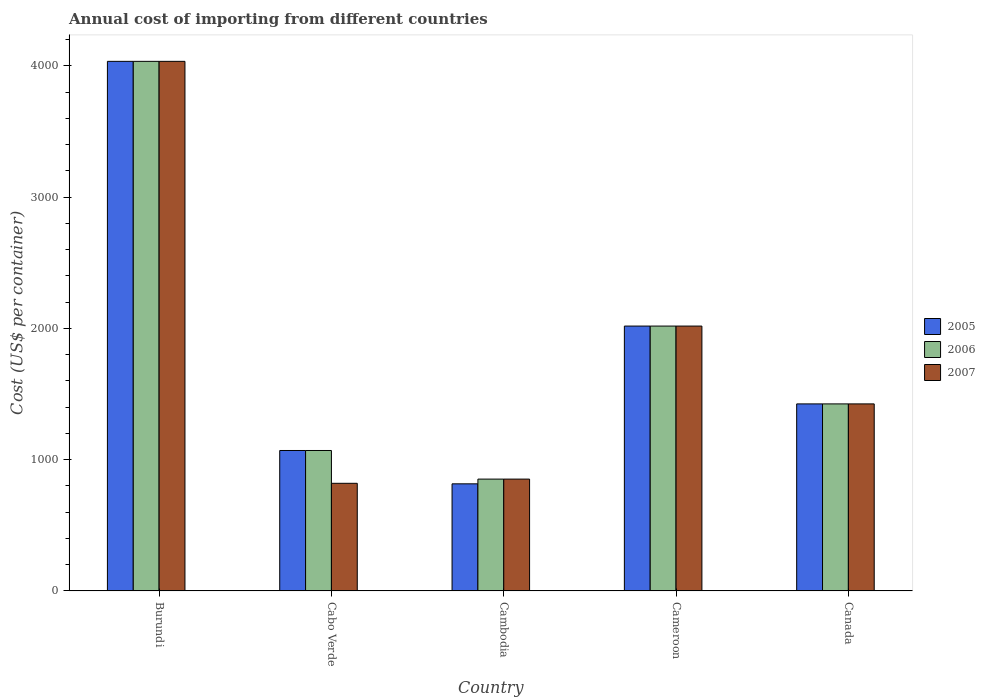How many bars are there on the 3rd tick from the right?
Your answer should be compact. 3. What is the label of the 3rd group of bars from the left?
Offer a very short reply. Cambodia. In how many cases, is the number of bars for a given country not equal to the number of legend labels?
Provide a succinct answer. 0. What is the total annual cost of importing in 2006 in Cameroon?
Keep it short and to the point. 2018. Across all countries, what is the maximum total annual cost of importing in 2007?
Provide a short and direct response. 4035. Across all countries, what is the minimum total annual cost of importing in 2007?
Offer a very short reply. 820. In which country was the total annual cost of importing in 2007 maximum?
Give a very brief answer. Burundi. In which country was the total annual cost of importing in 2006 minimum?
Ensure brevity in your answer.  Cambodia. What is the total total annual cost of importing in 2005 in the graph?
Ensure brevity in your answer.  9364. What is the difference between the total annual cost of importing in 2007 in Cabo Verde and that in Cameroon?
Provide a succinct answer. -1198. What is the difference between the total annual cost of importing in 2007 in Cameroon and the total annual cost of importing in 2005 in Cabo Verde?
Offer a very short reply. 948. What is the average total annual cost of importing in 2007 per country?
Make the answer very short. 1830. What is the difference between the total annual cost of importing of/in 2007 and total annual cost of importing of/in 2006 in Cambodia?
Provide a succinct answer. 0. In how many countries, is the total annual cost of importing in 2006 greater than 200 US$?
Offer a terse response. 5. What is the ratio of the total annual cost of importing in 2005 in Cabo Verde to that in Cambodia?
Ensure brevity in your answer.  1.31. Is the total annual cost of importing in 2005 in Cambodia less than that in Canada?
Ensure brevity in your answer.  Yes. What is the difference between the highest and the second highest total annual cost of importing in 2005?
Ensure brevity in your answer.  -593. What is the difference between the highest and the lowest total annual cost of importing in 2006?
Make the answer very short. 3183. In how many countries, is the total annual cost of importing in 2007 greater than the average total annual cost of importing in 2007 taken over all countries?
Your response must be concise. 2. What does the 3rd bar from the left in Cambodia represents?
Your answer should be very brief. 2007. What does the 1st bar from the right in Cambodia represents?
Offer a very short reply. 2007. Is it the case that in every country, the sum of the total annual cost of importing in 2007 and total annual cost of importing in 2005 is greater than the total annual cost of importing in 2006?
Your answer should be compact. Yes. Are all the bars in the graph horizontal?
Offer a terse response. No. How many countries are there in the graph?
Provide a succinct answer. 5. Does the graph contain grids?
Give a very brief answer. No. Where does the legend appear in the graph?
Make the answer very short. Center right. What is the title of the graph?
Offer a terse response. Annual cost of importing from different countries. What is the label or title of the X-axis?
Make the answer very short. Country. What is the label or title of the Y-axis?
Your answer should be very brief. Cost (US$ per container). What is the Cost (US$ per container) of 2005 in Burundi?
Your answer should be very brief. 4035. What is the Cost (US$ per container) of 2006 in Burundi?
Offer a terse response. 4035. What is the Cost (US$ per container) in 2007 in Burundi?
Make the answer very short. 4035. What is the Cost (US$ per container) in 2005 in Cabo Verde?
Your answer should be very brief. 1070. What is the Cost (US$ per container) in 2006 in Cabo Verde?
Offer a very short reply. 1070. What is the Cost (US$ per container) in 2007 in Cabo Verde?
Keep it short and to the point. 820. What is the Cost (US$ per container) in 2005 in Cambodia?
Your answer should be very brief. 816. What is the Cost (US$ per container) of 2006 in Cambodia?
Provide a succinct answer. 852. What is the Cost (US$ per container) in 2007 in Cambodia?
Offer a terse response. 852. What is the Cost (US$ per container) of 2005 in Cameroon?
Ensure brevity in your answer.  2018. What is the Cost (US$ per container) in 2006 in Cameroon?
Your response must be concise. 2018. What is the Cost (US$ per container) in 2007 in Cameroon?
Keep it short and to the point. 2018. What is the Cost (US$ per container) in 2005 in Canada?
Ensure brevity in your answer.  1425. What is the Cost (US$ per container) in 2006 in Canada?
Your response must be concise. 1425. What is the Cost (US$ per container) in 2007 in Canada?
Keep it short and to the point. 1425. Across all countries, what is the maximum Cost (US$ per container) in 2005?
Make the answer very short. 4035. Across all countries, what is the maximum Cost (US$ per container) of 2006?
Give a very brief answer. 4035. Across all countries, what is the maximum Cost (US$ per container) of 2007?
Provide a succinct answer. 4035. Across all countries, what is the minimum Cost (US$ per container) in 2005?
Keep it short and to the point. 816. Across all countries, what is the minimum Cost (US$ per container) of 2006?
Your answer should be compact. 852. Across all countries, what is the minimum Cost (US$ per container) in 2007?
Keep it short and to the point. 820. What is the total Cost (US$ per container) of 2005 in the graph?
Give a very brief answer. 9364. What is the total Cost (US$ per container) of 2006 in the graph?
Provide a short and direct response. 9400. What is the total Cost (US$ per container) in 2007 in the graph?
Keep it short and to the point. 9150. What is the difference between the Cost (US$ per container) of 2005 in Burundi and that in Cabo Verde?
Make the answer very short. 2965. What is the difference between the Cost (US$ per container) of 2006 in Burundi and that in Cabo Verde?
Provide a succinct answer. 2965. What is the difference between the Cost (US$ per container) in 2007 in Burundi and that in Cabo Verde?
Provide a succinct answer. 3215. What is the difference between the Cost (US$ per container) in 2005 in Burundi and that in Cambodia?
Offer a terse response. 3219. What is the difference between the Cost (US$ per container) in 2006 in Burundi and that in Cambodia?
Ensure brevity in your answer.  3183. What is the difference between the Cost (US$ per container) of 2007 in Burundi and that in Cambodia?
Your answer should be very brief. 3183. What is the difference between the Cost (US$ per container) of 2005 in Burundi and that in Cameroon?
Your answer should be compact. 2017. What is the difference between the Cost (US$ per container) of 2006 in Burundi and that in Cameroon?
Your response must be concise. 2017. What is the difference between the Cost (US$ per container) in 2007 in Burundi and that in Cameroon?
Your response must be concise. 2017. What is the difference between the Cost (US$ per container) of 2005 in Burundi and that in Canada?
Make the answer very short. 2610. What is the difference between the Cost (US$ per container) in 2006 in Burundi and that in Canada?
Make the answer very short. 2610. What is the difference between the Cost (US$ per container) in 2007 in Burundi and that in Canada?
Provide a succinct answer. 2610. What is the difference between the Cost (US$ per container) of 2005 in Cabo Verde and that in Cambodia?
Keep it short and to the point. 254. What is the difference between the Cost (US$ per container) of 2006 in Cabo Verde and that in Cambodia?
Provide a succinct answer. 218. What is the difference between the Cost (US$ per container) of 2007 in Cabo Verde and that in Cambodia?
Provide a short and direct response. -32. What is the difference between the Cost (US$ per container) in 2005 in Cabo Verde and that in Cameroon?
Your answer should be very brief. -948. What is the difference between the Cost (US$ per container) in 2006 in Cabo Verde and that in Cameroon?
Your answer should be very brief. -948. What is the difference between the Cost (US$ per container) in 2007 in Cabo Verde and that in Cameroon?
Keep it short and to the point. -1198. What is the difference between the Cost (US$ per container) in 2005 in Cabo Verde and that in Canada?
Your response must be concise. -355. What is the difference between the Cost (US$ per container) of 2006 in Cabo Verde and that in Canada?
Offer a very short reply. -355. What is the difference between the Cost (US$ per container) in 2007 in Cabo Verde and that in Canada?
Give a very brief answer. -605. What is the difference between the Cost (US$ per container) in 2005 in Cambodia and that in Cameroon?
Your answer should be very brief. -1202. What is the difference between the Cost (US$ per container) of 2006 in Cambodia and that in Cameroon?
Your answer should be very brief. -1166. What is the difference between the Cost (US$ per container) of 2007 in Cambodia and that in Cameroon?
Your answer should be compact. -1166. What is the difference between the Cost (US$ per container) of 2005 in Cambodia and that in Canada?
Offer a very short reply. -609. What is the difference between the Cost (US$ per container) of 2006 in Cambodia and that in Canada?
Provide a short and direct response. -573. What is the difference between the Cost (US$ per container) of 2007 in Cambodia and that in Canada?
Your answer should be compact. -573. What is the difference between the Cost (US$ per container) of 2005 in Cameroon and that in Canada?
Provide a short and direct response. 593. What is the difference between the Cost (US$ per container) of 2006 in Cameroon and that in Canada?
Provide a short and direct response. 593. What is the difference between the Cost (US$ per container) in 2007 in Cameroon and that in Canada?
Make the answer very short. 593. What is the difference between the Cost (US$ per container) of 2005 in Burundi and the Cost (US$ per container) of 2006 in Cabo Verde?
Provide a short and direct response. 2965. What is the difference between the Cost (US$ per container) in 2005 in Burundi and the Cost (US$ per container) in 2007 in Cabo Verde?
Your response must be concise. 3215. What is the difference between the Cost (US$ per container) in 2006 in Burundi and the Cost (US$ per container) in 2007 in Cabo Verde?
Provide a succinct answer. 3215. What is the difference between the Cost (US$ per container) in 2005 in Burundi and the Cost (US$ per container) in 2006 in Cambodia?
Give a very brief answer. 3183. What is the difference between the Cost (US$ per container) of 2005 in Burundi and the Cost (US$ per container) of 2007 in Cambodia?
Ensure brevity in your answer.  3183. What is the difference between the Cost (US$ per container) of 2006 in Burundi and the Cost (US$ per container) of 2007 in Cambodia?
Your answer should be very brief. 3183. What is the difference between the Cost (US$ per container) of 2005 in Burundi and the Cost (US$ per container) of 2006 in Cameroon?
Your response must be concise. 2017. What is the difference between the Cost (US$ per container) in 2005 in Burundi and the Cost (US$ per container) in 2007 in Cameroon?
Your response must be concise. 2017. What is the difference between the Cost (US$ per container) of 2006 in Burundi and the Cost (US$ per container) of 2007 in Cameroon?
Your response must be concise. 2017. What is the difference between the Cost (US$ per container) of 2005 in Burundi and the Cost (US$ per container) of 2006 in Canada?
Provide a short and direct response. 2610. What is the difference between the Cost (US$ per container) of 2005 in Burundi and the Cost (US$ per container) of 2007 in Canada?
Offer a terse response. 2610. What is the difference between the Cost (US$ per container) of 2006 in Burundi and the Cost (US$ per container) of 2007 in Canada?
Offer a very short reply. 2610. What is the difference between the Cost (US$ per container) of 2005 in Cabo Verde and the Cost (US$ per container) of 2006 in Cambodia?
Offer a very short reply. 218. What is the difference between the Cost (US$ per container) of 2005 in Cabo Verde and the Cost (US$ per container) of 2007 in Cambodia?
Make the answer very short. 218. What is the difference between the Cost (US$ per container) in 2006 in Cabo Verde and the Cost (US$ per container) in 2007 in Cambodia?
Offer a very short reply. 218. What is the difference between the Cost (US$ per container) of 2005 in Cabo Verde and the Cost (US$ per container) of 2006 in Cameroon?
Give a very brief answer. -948. What is the difference between the Cost (US$ per container) in 2005 in Cabo Verde and the Cost (US$ per container) in 2007 in Cameroon?
Offer a terse response. -948. What is the difference between the Cost (US$ per container) of 2006 in Cabo Verde and the Cost (US$ per container) of 2007 in Cameroon?
Your answer should be compact. -948. What is the difference between the Cost (US$ per container) in 2005 in Cabo Verde and the Cost (US$ per container) in 2006 in Canada?
Ensure brevity in your answer.  -355. What is the difference between the Cost (US$ per container) in 2005 in Cabo Verde and the Cost (US$ per container) in 2007 in Canada?
Give a very brief answer. -355. What is the difference between the Cost (US$ per container) of 2006 in Cabo Verde and the Cost (US$ per container) of 2007 in Canada?
Offer a very short reply. -355. What is the difference between the Cost (US$ per container) of 2005 in Cambodia and the Cost (US$ per container) of 2006 in Cameroon?
Give a very brief answer. -1202. What is the difference between the Cost (US$ per container) of 2005 in Cambodia and the Cost (US$ per container) of 2007 in Cameroon?
Your answer should be compact. -1202. What is the difference between the Cost (US$ per container) of 2006 in Cambodia and the Cost (US$ per container) of 2007 in Cameroon?
Your answer should be very brief. -1166. What is the difference between the Cost (US$ per container) of 2005 in Cambodia and the Cost (US$ per container) of 2006 in Canada?
Provide a short and direct response. -609. What is the difference between the Cost (US$ per container) of 2005 in Cambodia and the Cost (US$ per container) of 2007 in Canada?
Keep it short and to the point. -609. What is the difference between the Cost (US$ per container) in 2006 in Cambodia and the Cost (US$ per container) in 2007 in Canada?
Keep it short and to the point. -573. What is the difference between the Cost (US$ per container) of 2005 in Cameroon and the Cost (US$ per container) of 2006 in Canada?
Your answer should be compact. 593. What is the difference between the Cost (US$ per container) of 2005 in Cameroon and the Cost (US$ per container) of 2007 in Canada?
Ensure brevity in your answer.  593. What is the difference between the Cost (US$ per container) in 2006 in Cameroon and the Cost (US$ per container) in 2007 in Canada?
Your answer should be compact. 593. What is the average Cost (US$ per container) in 2005 per country?
Your answer should be compact. 1872.8. What is the average Cost (US$ per container) of 2006 per country?
Offer a terse response. 1880. What is the average Cost (US$ per container) of 2007 per country?
Offer a very short reply. 1830. What is the difference between the Cost (US$ per container) of 2005 and Cost (US$ per container) of 2006 in Cabo Verde?
Your answer should be very brief. 0. What is the difference between the Cost (US$ per container) in 2005 and Cost (US$ per container) in 2007 in Cabo Verde?
Offer a terse response. 250. What is the difference between the Cost (US$ per container) in 2006 and Cost (US$ per container) in 2007 in Cabo Verde?
Make the answer very short. 250. What is the difference between the Cost (US$ per container) of 2005 and Cost (US$ per container) of 2006 in Cambodia?
Your answer should be very brief. -36. What is the difference between the Cost (US$ per container) of 2005 and Cost (US$ per container) of 2007 in Cambodia?
Your answer should be very brief. -36. What is the difference between the Cost (US$ per container) in 2006 and Cost (US$ per container) in 2007 in Cambodia?
Keep it short and to the point. 0. What is the difference between the Cost (US$ per container) in 2005 and Cost (US$ per container) in 2006 in Cameroon?
Your answer should be very brief. 0. What is the difference between the Cost (US$ per container) in 2005 and Cost (US$ per container) in 2007 in Canada?
Provide a short and direct response. 0. What is the ratio of the Cost (US$ per container) of 2005 in Burundi to that in Cabo Verde?
Your answer should be very brief. 3.77. What is the ratio of the Cost (US$ per container) of 2006 in Burundi to that in Cabo Verde?
Provide a short and direct response. 3.77. What is the ratio of the Cost (US$ per container) of 2007 in Burundi to that in Cabo Verde?
Your answer should be compact. 4.92. What is the ratio of the Cost (US$ per container) in 2005 in Burundi to that in Cambodia?
Give a very brief answer. 4.94. What is the ratio of the Cost (US$ per container) in 2006 in Burundi to that in Cambodia?
Your answer should be compact. 4.74. What is the ratio of the Cost (US$ per container) in 2007 in Burundi to that in Cambodia?
Make the answer very short. 4.74. What is the ratio of the Cost (US$ per container) of 2005 in Burundi to that in Cameroon?
Ensure brevity in your answer.  2. What is the ratio of the Cost (US$ per container) in 2006 in Burundi to that in Cameroon?
Keep it short and to the point. 2. What is the ratio of the Cost (US$ per container) in 2007 in Burundi to that in Cameroon?
Your answer should be compact. 2. What is the ratio of the Cost (US$ per container) of 2005 in Burundi to that in Canada?
Give a very brief answer. 2.83. What is the ratio of the Cost (US$ per container) of 2006 in Burundi to that in Canada?
Give a very brief answer. 2.83. What is the ratio of the Cost (US$ per container) of 2007 in Burundi to that in Canada?
Ensure brevity in your answer.  2.83. What is the ratio of the Cost (US$ per container) of 2005 in Cabo Verde to that in Cambodia?
Your response must be concise. 1.31. What is the ratio of the Cost (US$ per container) of 2006 in Cabo Verde to that in Cambodia?
Offer a very short reply. 1.26. What is the ratio of the Cost (US$ per container) of 2007 in Cabo Verde to that in Cambodia?
Offer a very short reply. 0.96. What is the ratio of the Cost (US$ per container) in 2005 in Cabo Verde to that in Cameroon?
Provide a succinct answer. 0.53. What is the ratio of the Cost (US$ per container) of 2006 in Cabo Verde to that in Cameroon?
Keep it short and to the point. 0.53. What is the ratio of the Cost (US$ per container) in 2007 in Cabo Verde to that in Cameroon?
Your answer should be compact. 0.41. What is the ratio of the Cost (US$ per container) in 2005 in Cabo Verde to that in Canada?
Keep it short and to the point. 0.75. What is the ratio of the Cost (US$ per container) of 2006 in Cabo Verde to that in Canada?
Provide a succinct answer. 0.75. What is the ratio of the Cost (US$ per container) of 2007 in Cabo Verde to that in Canada?
Provide a short and direct response. 0.58. What is the ratio of the Cost (US$ per container) in 2005 in Cambodia to that in Cameroon?
Provide a short and direct response. 0.4. What is the ratio of the Cost (US$ per container) of 2006 in Cambodia to that in Cameroon?
Ensure brevity in your answer.  0.42. What is the ratio of the Cost (US$ per container) of 2007 in Cambodia to that in Cameroon?
Provide a short and direct response. 0.42. What is the ratio of the Cost (US$ per container) of 2005 in Cambodia to that in Canada?
Keep it short and to the point. 0.57. What is the ratio of the Cost (US$ per container) in 2006 in Cambodia to that in Canada?
Your answer should be very brief. 0.6. What is the ratio of the Cost (US$ per container) in 2007 in Cambodia to that in Canada?
Offer a very short reply. 0.6. What is the ratio of the Cost (US$ per container) of 2005 in Cameroon to that in Canada?
Provide a succinct answer. 1.42. What is the ratio of the Cost (US$ per container) in 2006 in Cameroon to that in Canada?
Your answer should be very brief. 1.42. What is the ratio of the Cost (US$ per container) of 2007 in Cameroon to that in Canada?
Your answer should be very brief. 1.42. What is the difference between the highest and the second highest Cost (US$ per container) of 2005?
Your answer should be very brief. 2017. What is the difference between the highest and the second highest Cost (US$ per container) of 2006?
Make the answer very short. 2017. What is the difference between the highest and the second highest Cost (US$ per container) of 2007?
Give a very brief answer. 2017. What is the difference between the highest and the lowest Cost (US$ per container) of 2005?
Keep it short and to the point. 3219. What is the difference between the highest and the lowest Cost (US$ per container) of 2006?
Provide a succinct answer. 3183. What is the difference between the highest and the lowest Cost (US$ per container) of 2007?
Offer a very short reply. 3215. 